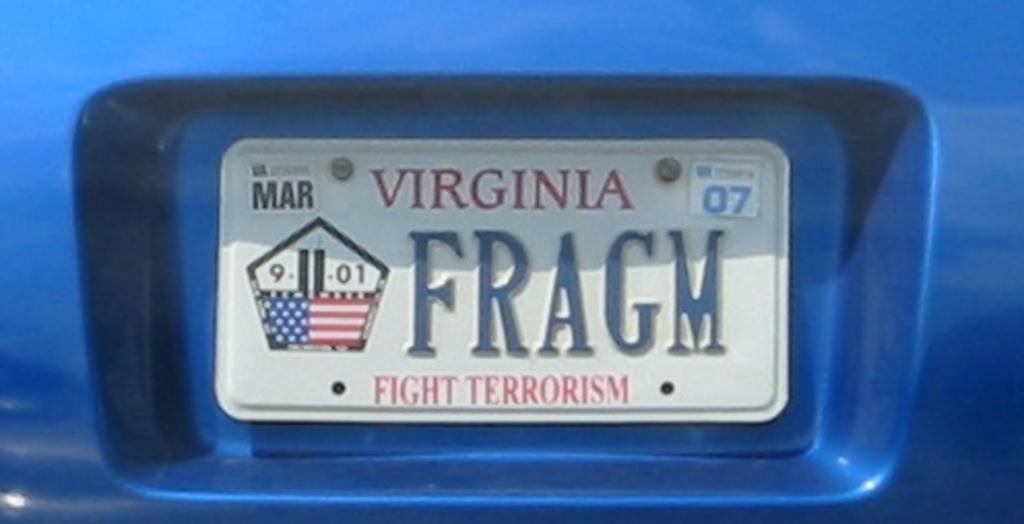Which state issue this licence plate?
Your answer should be very brief. Virginia. What is the license plate number?
Make the answer very short. Fragm. 